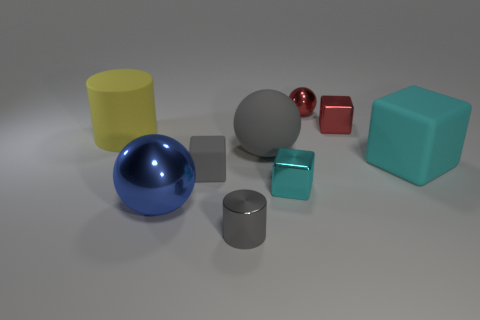Does the image seem to depict a real-life scenario or is it computer-generated? The image appears to be computer-generated, likely a rendering designed to showcase different geometric shapes and textures in a controlled lighting environment.  Are there any patterns or consistency in shapes or colors among the objects? Yes, the objects seem deliberately picked to represent basic geometric shapes such as cylinders, spheres, and cubes. Each object is of a solid color, with no patterns or textures besides their gloss or matte finishes. The color palette seems carefully chosen for variety without any repeating colors. 